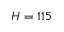Convert formula to latex. <formula><loc_0><loc_0><loc_500><loc_500>H = 1 1 5</formula> 